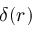<formula> <loc_0><loc_0><loc_500><loc_500>\delta ( \boldsymbol r )</formula> 